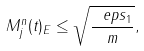Convert formula to latex. <formula><loc_0><loc_0><loc_500><loc_500>\| M _ { j } ^ { n } ( t ) \| _ { E } \leq \sqrt { \frac { \ e p s _ { 1 } } { m } } ,</formula> 